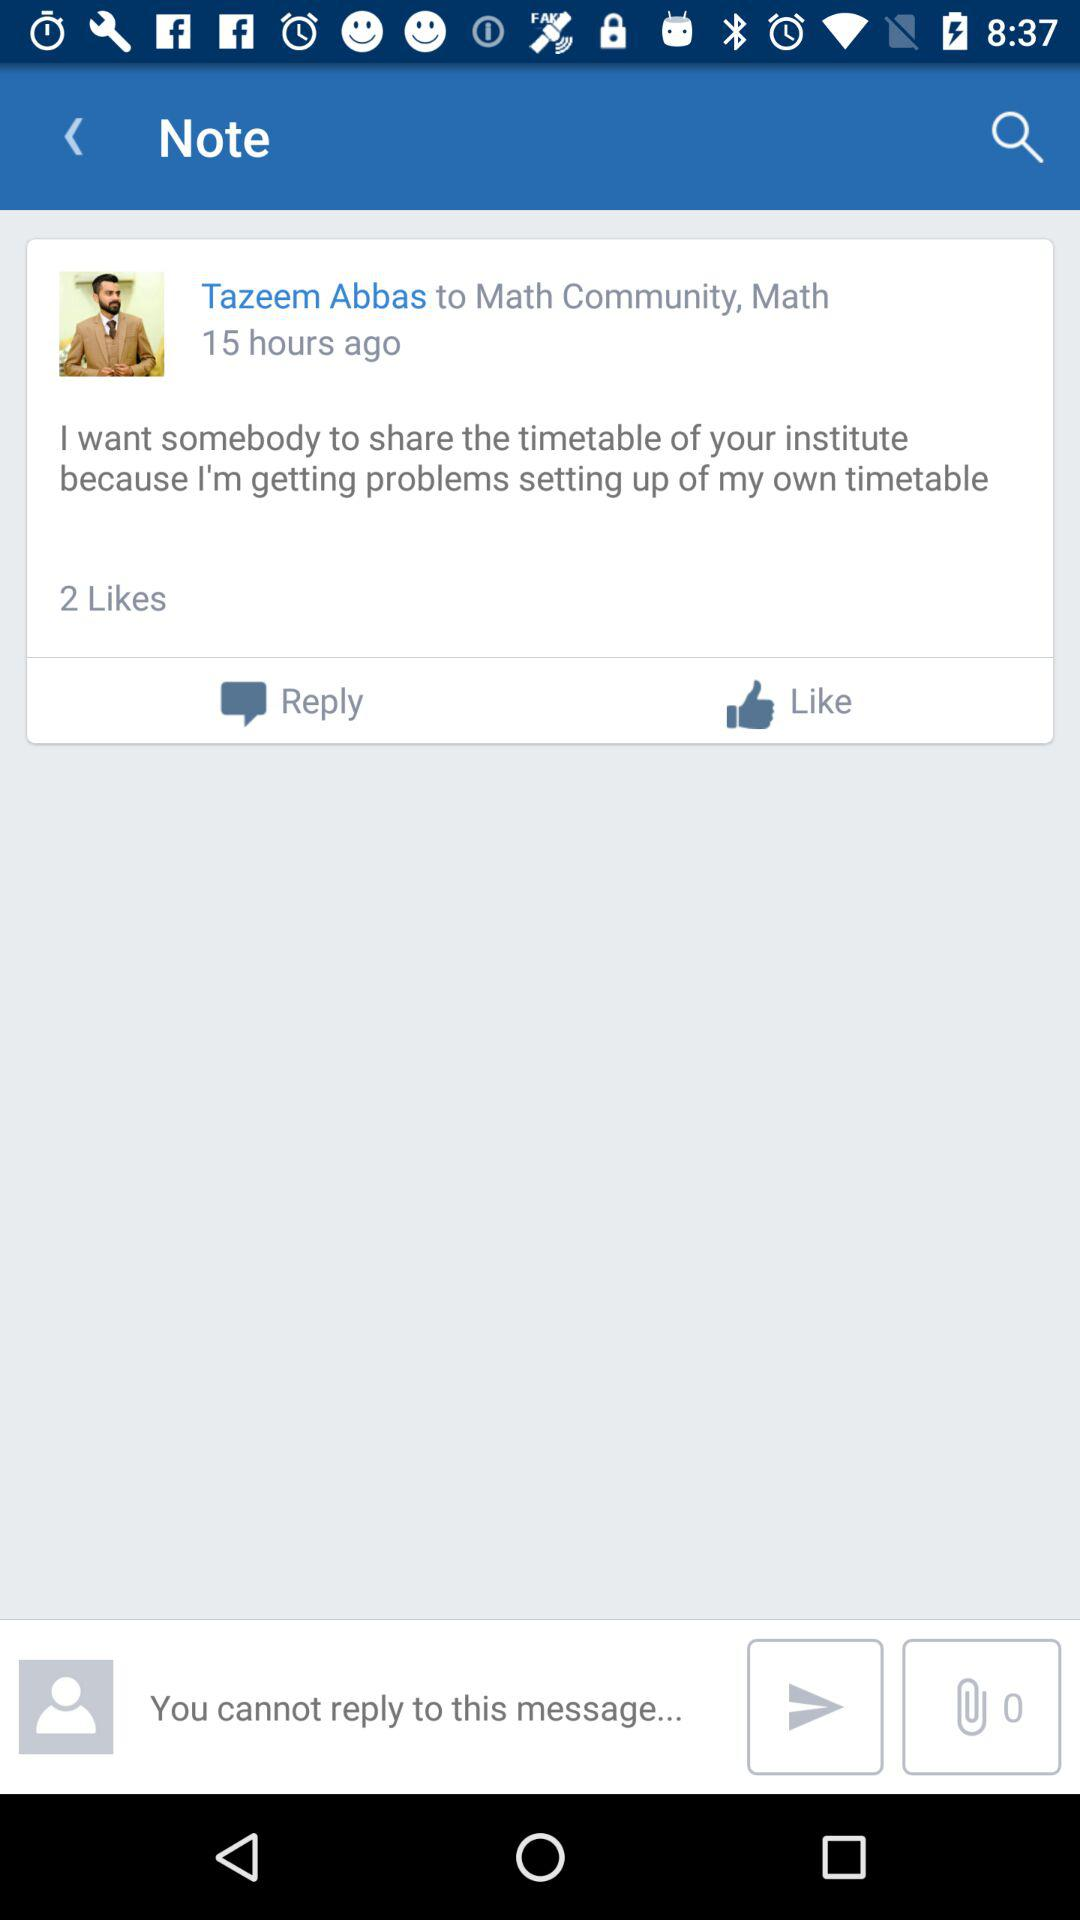How many hours ago was the note posted?
Answer the question using a single word or phrase. 15 